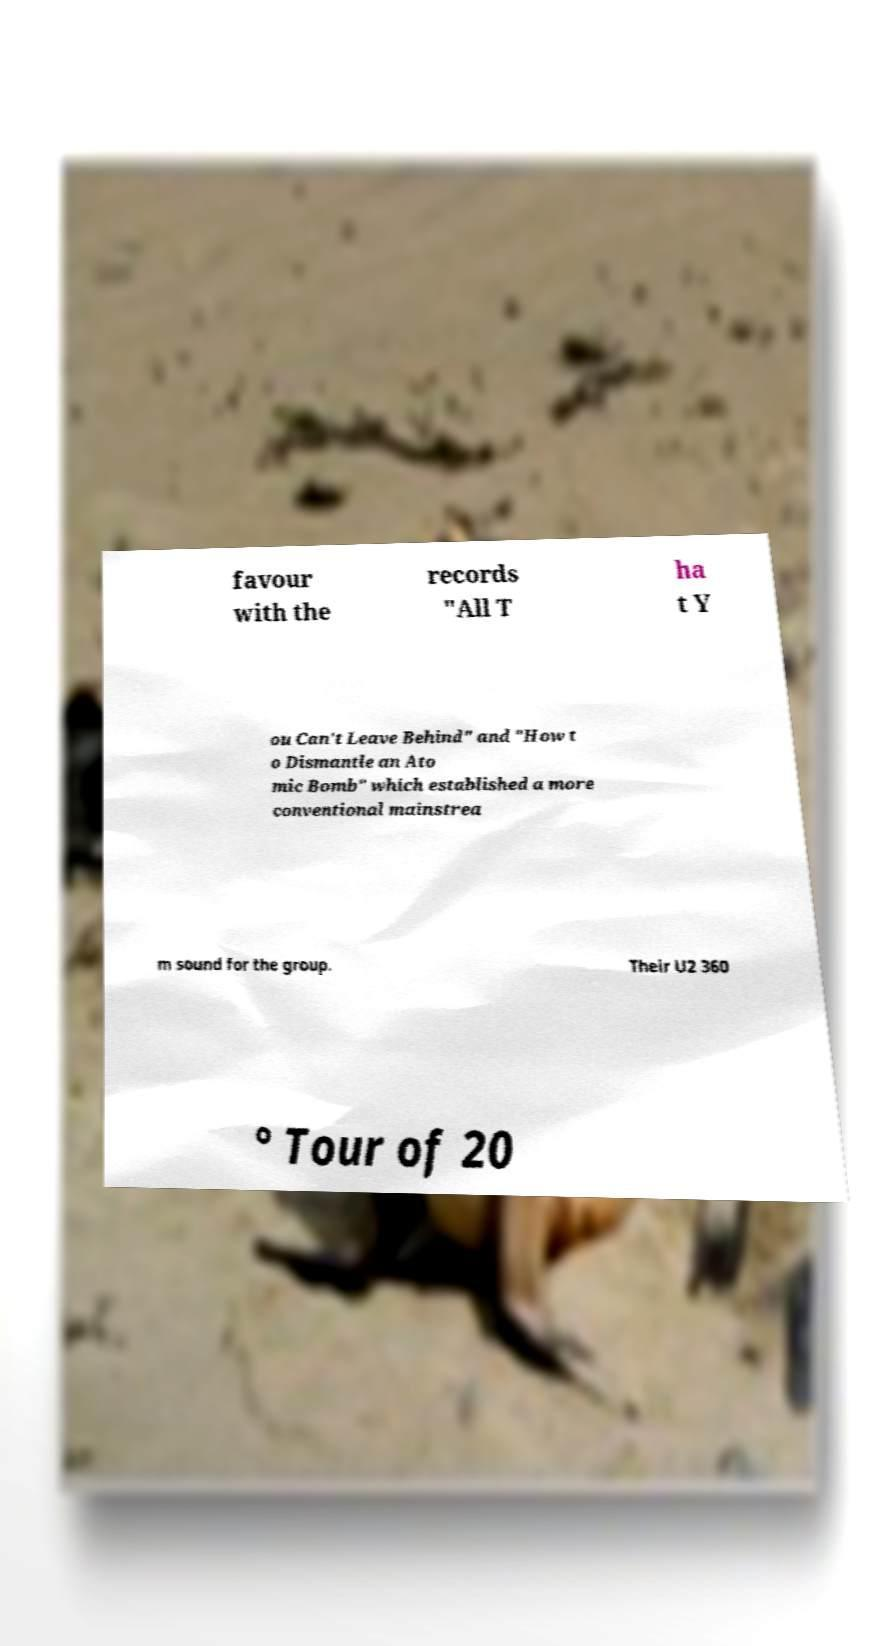Can you read and provide the text displayed in the image?This photo seems to have some interesting text. Can you extract and type it out for me? favour with the records "All T ha t Y ou Can't Leave Behind" and "How t o Dismantle an Ato mic Bomb" which established a more conventional mainstrea m sound for the group. Their U2 360 ° Tour of 20 